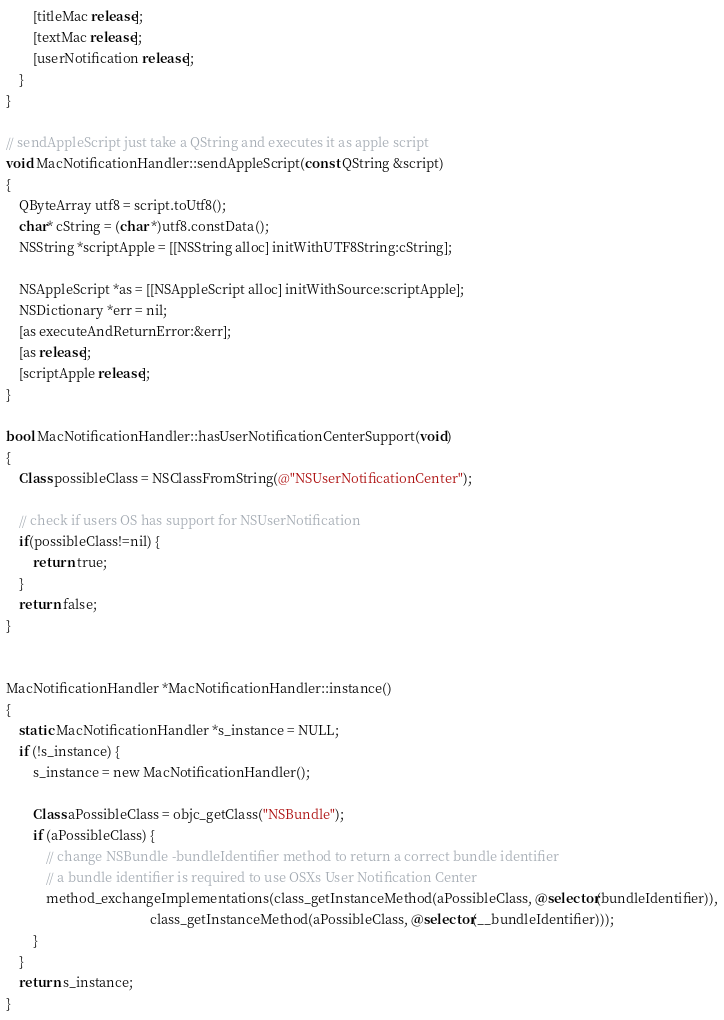Convert code to text. <code><loc_0><loc_0><loc_500><loc_500><_ObjectiveC_>
        [titleMac release];
        [textMac release];
        [userNotification release];
    }
}

// sendAppleScript just take a QString and executes it as apple script
void MacNotificationHandler::sendAppleScript(const QString &script)
{
    QByteArray utf8 = script.toUtf8();
    char* cString = (char *)utf8.constData();
    NSString *scriptApple = [[NSString alloc] initWithUTF8String:cString];

    NSAppleScript *as = [[NSAppleScript alloc] initWithSource:scriptApple];
    NSDictionary *err = nil;
    [as executeAndReturnError:&err];
    [as release];
    [scriptApple release];
}

bool MacNotificationHandler::hasUserNotificationCenterSupport(void)
{
    Class possibleClass = NSClassFromString(@"NSUserNotificationCenter");

    // check if users OS has support for NSUserNotification
    if(possibleClass!=nil) {
        return true;
    }
    return false;
}


MacNotificationHandler *MacNotificationHandler::instance()
{
    static MacNotificationHandler *s_instance = NULL;
    if (!s_instance) {
        s_instance = new MacNotificationHandler();
        
        Class aPossibleClass = objc_getClass("NSBundle");
        if (aPossibleClass) {
            // change NSBundle -bundleIdentifier method to return a correct bundle identifier
            // a bundle identifier is required to use OSXs User Notification Center
            method_exchangeImplementations(class_getInstanceMethod(aPossibleClass, @selector(bundleIdentifier)),
                                           class_getInstanceMethod(aPossibleClass, @selector(__bundleIdentifier)));
        }
    }
    return s_instance;
}
</code> 